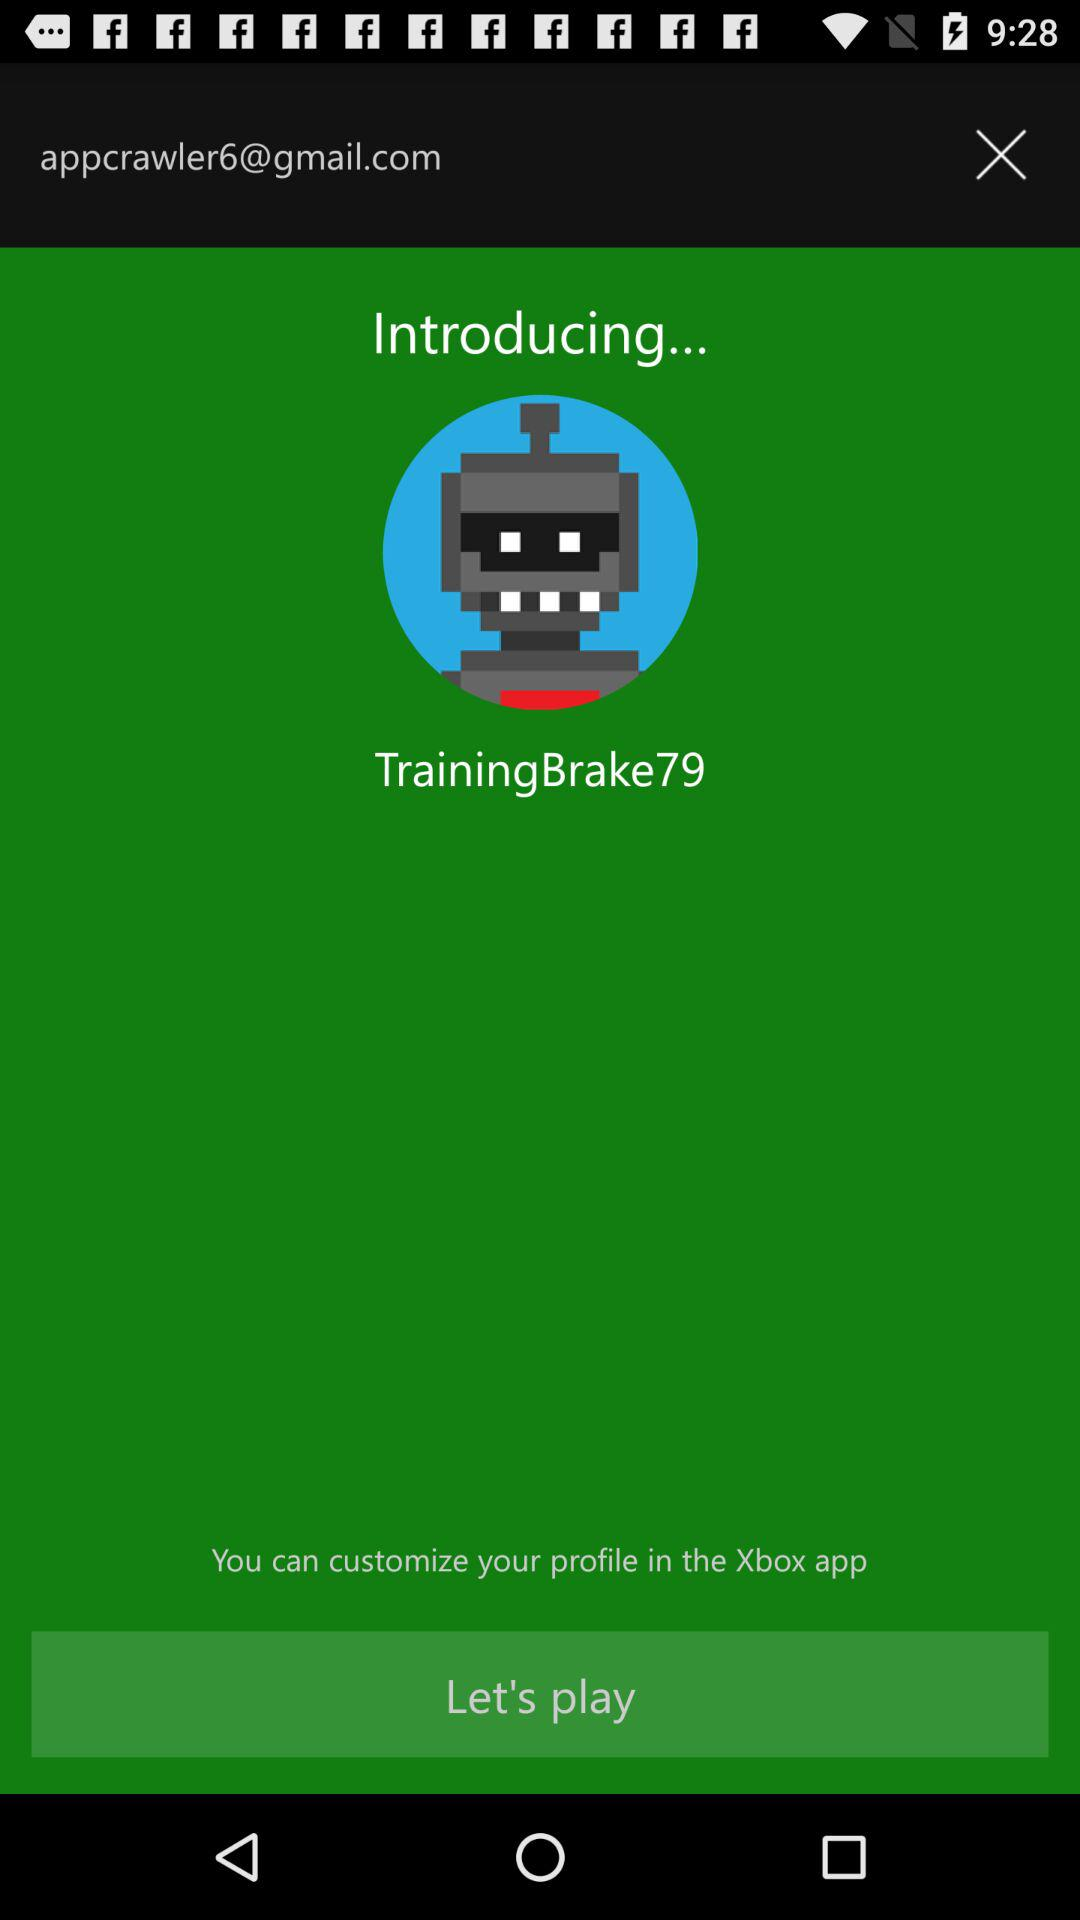What is the name of the user? The name of the user is "TrainingBrake79". 